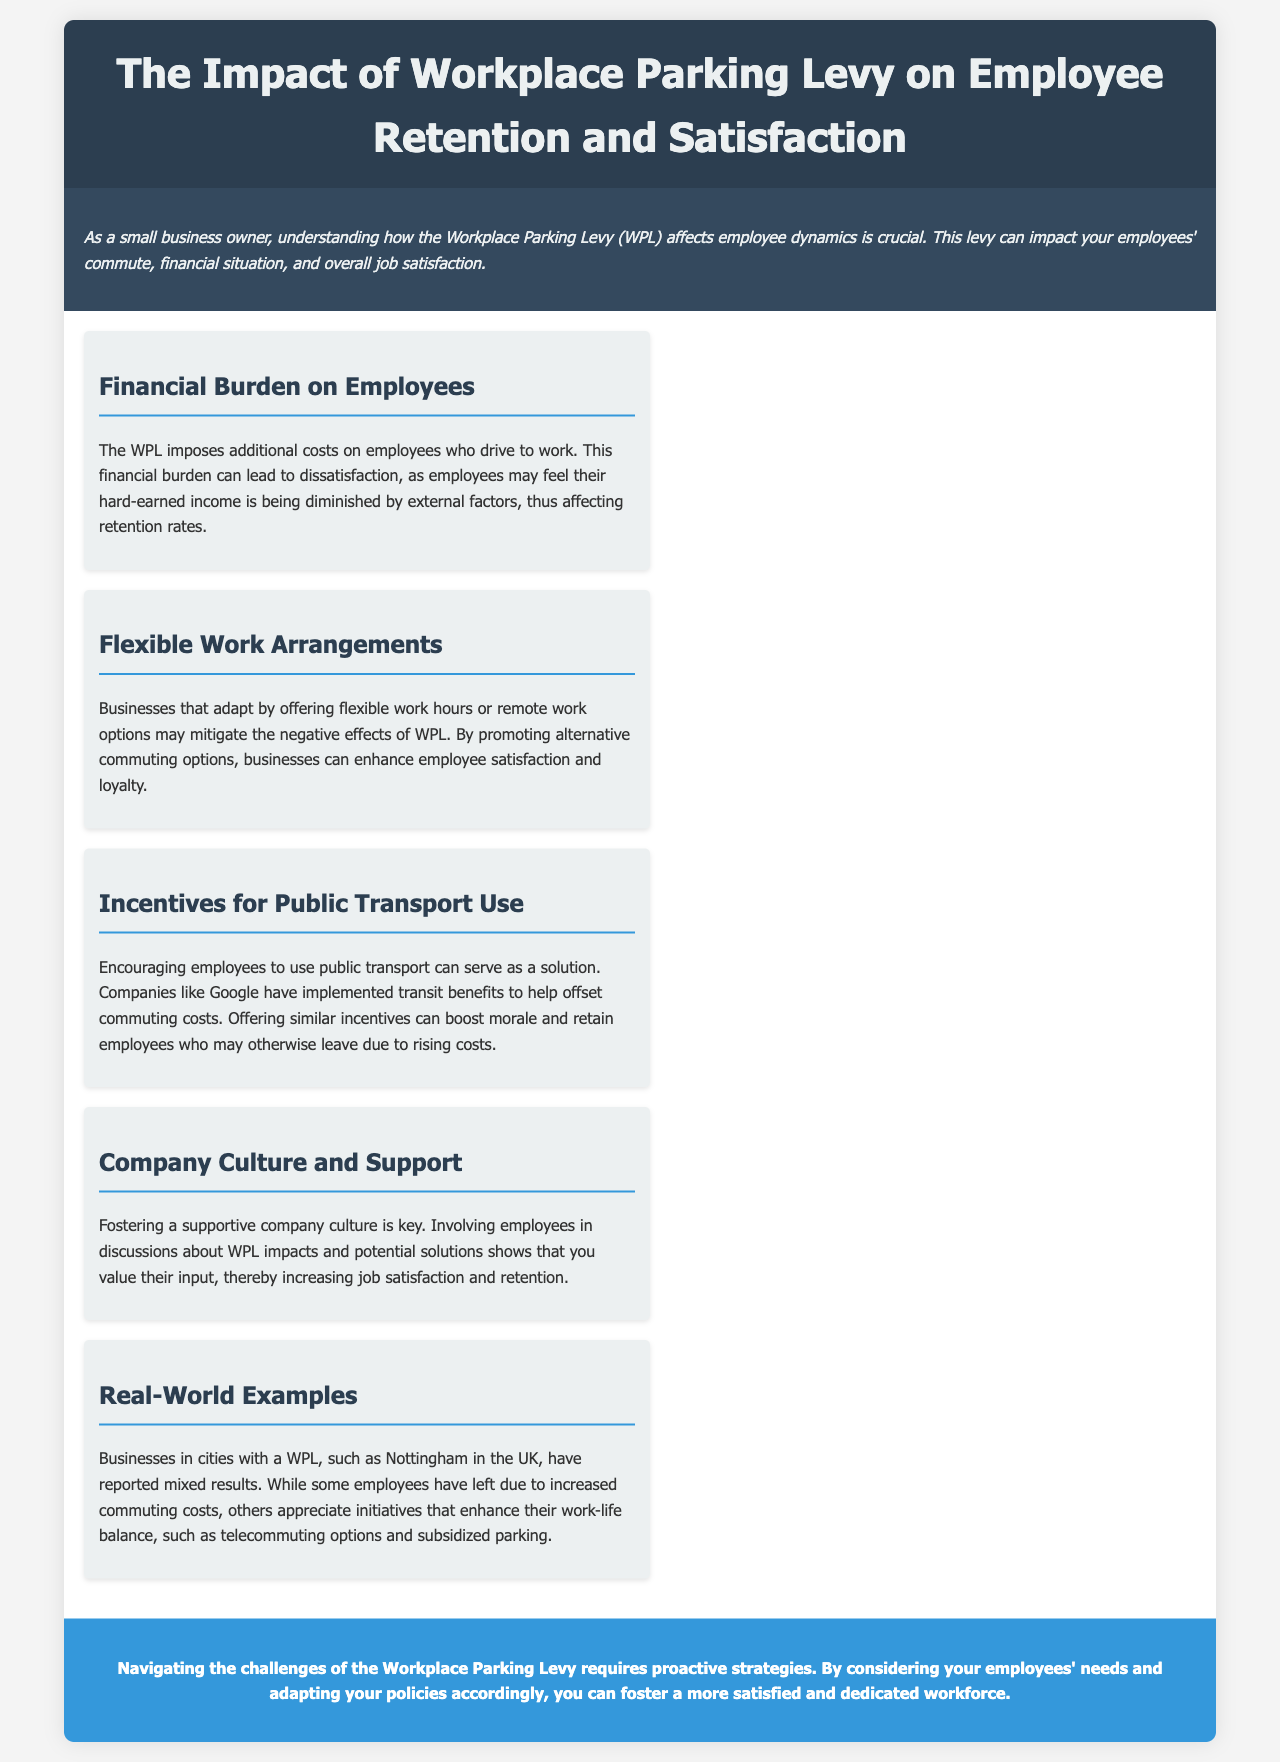What is the main topic of the brochure? The brochure discusses the impact of the Workplace Parking Levy on employee retention and satisfaction.
Answer: Workplace Parking Levy What is one potential negative effect of the WPL on employees? The brochure states that the financial burden can lead to dissatisfaction among employees.
Answer: Dissatisfaction What solution is suggested for businesses to mitigate negative effects of the WPL? It mentions that offering flexible work hours can help enhance employee satisfaction.
Answer: Flexible work hours Which company is mentioned as an example for implementing transit benefits? The document cites Google as a company that provides transit benefits to offset commuting costs.
Answer: Google What term is used to describe the initiatives that enhance work-life balance? The document refers to these initiatives as telecommuting options.
Answer: Telecommuting options Which city is provided as an example of one with a WPL? Nottingham is mentioned as a city that has experienced mixed results due to WPL.
Answer: Nottingham What aspect of company culture is emphasized in relation to employee satisfaction? The brochure emphasizes that fostering a supportive company culture is key to improving job satisfaction.
Answer: Supportive company culture What proactive strategy is recommended for managing WPL challenges? The document encourages businesses to adapt policies based on employee needs.
Answer: Adapt policies 